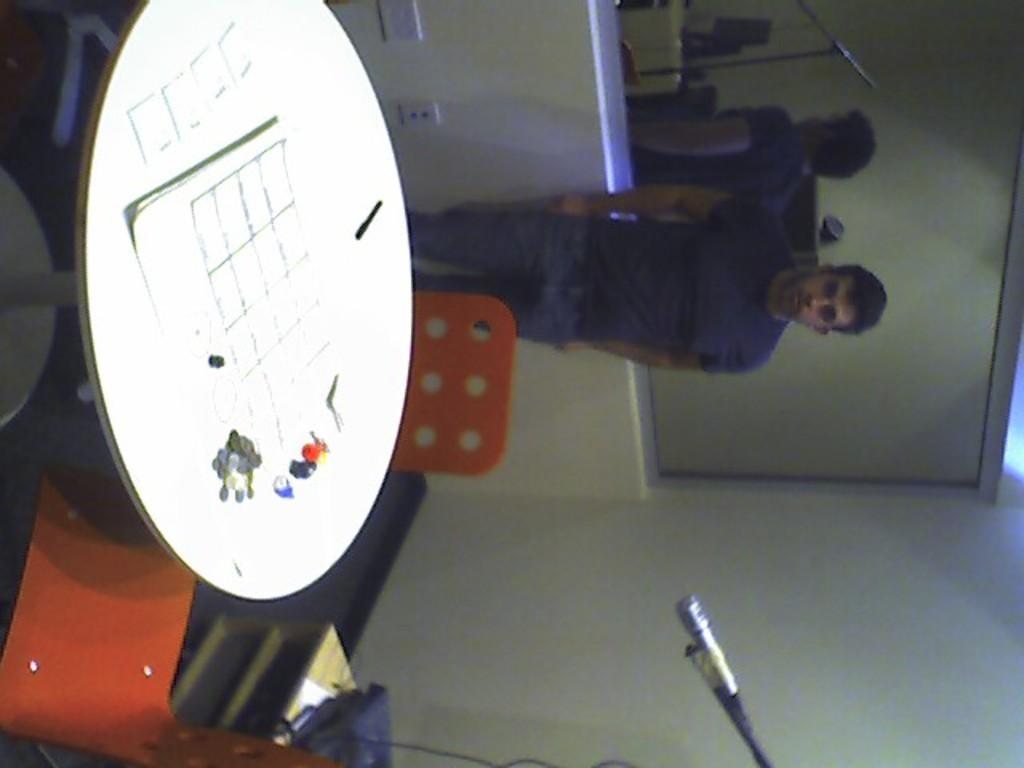Can you describe this image briefly? To the left corner of the image there is a table. Behind the table there are two orange chairs. To the bottom of the image behind the chair there is a small cupboard. And also in the middle of the image there is a mic. In the background there is a man with blue t-shirt is standing. Behind him to the wall there is a glass. Below the glass to the wall there is a switchboard.  